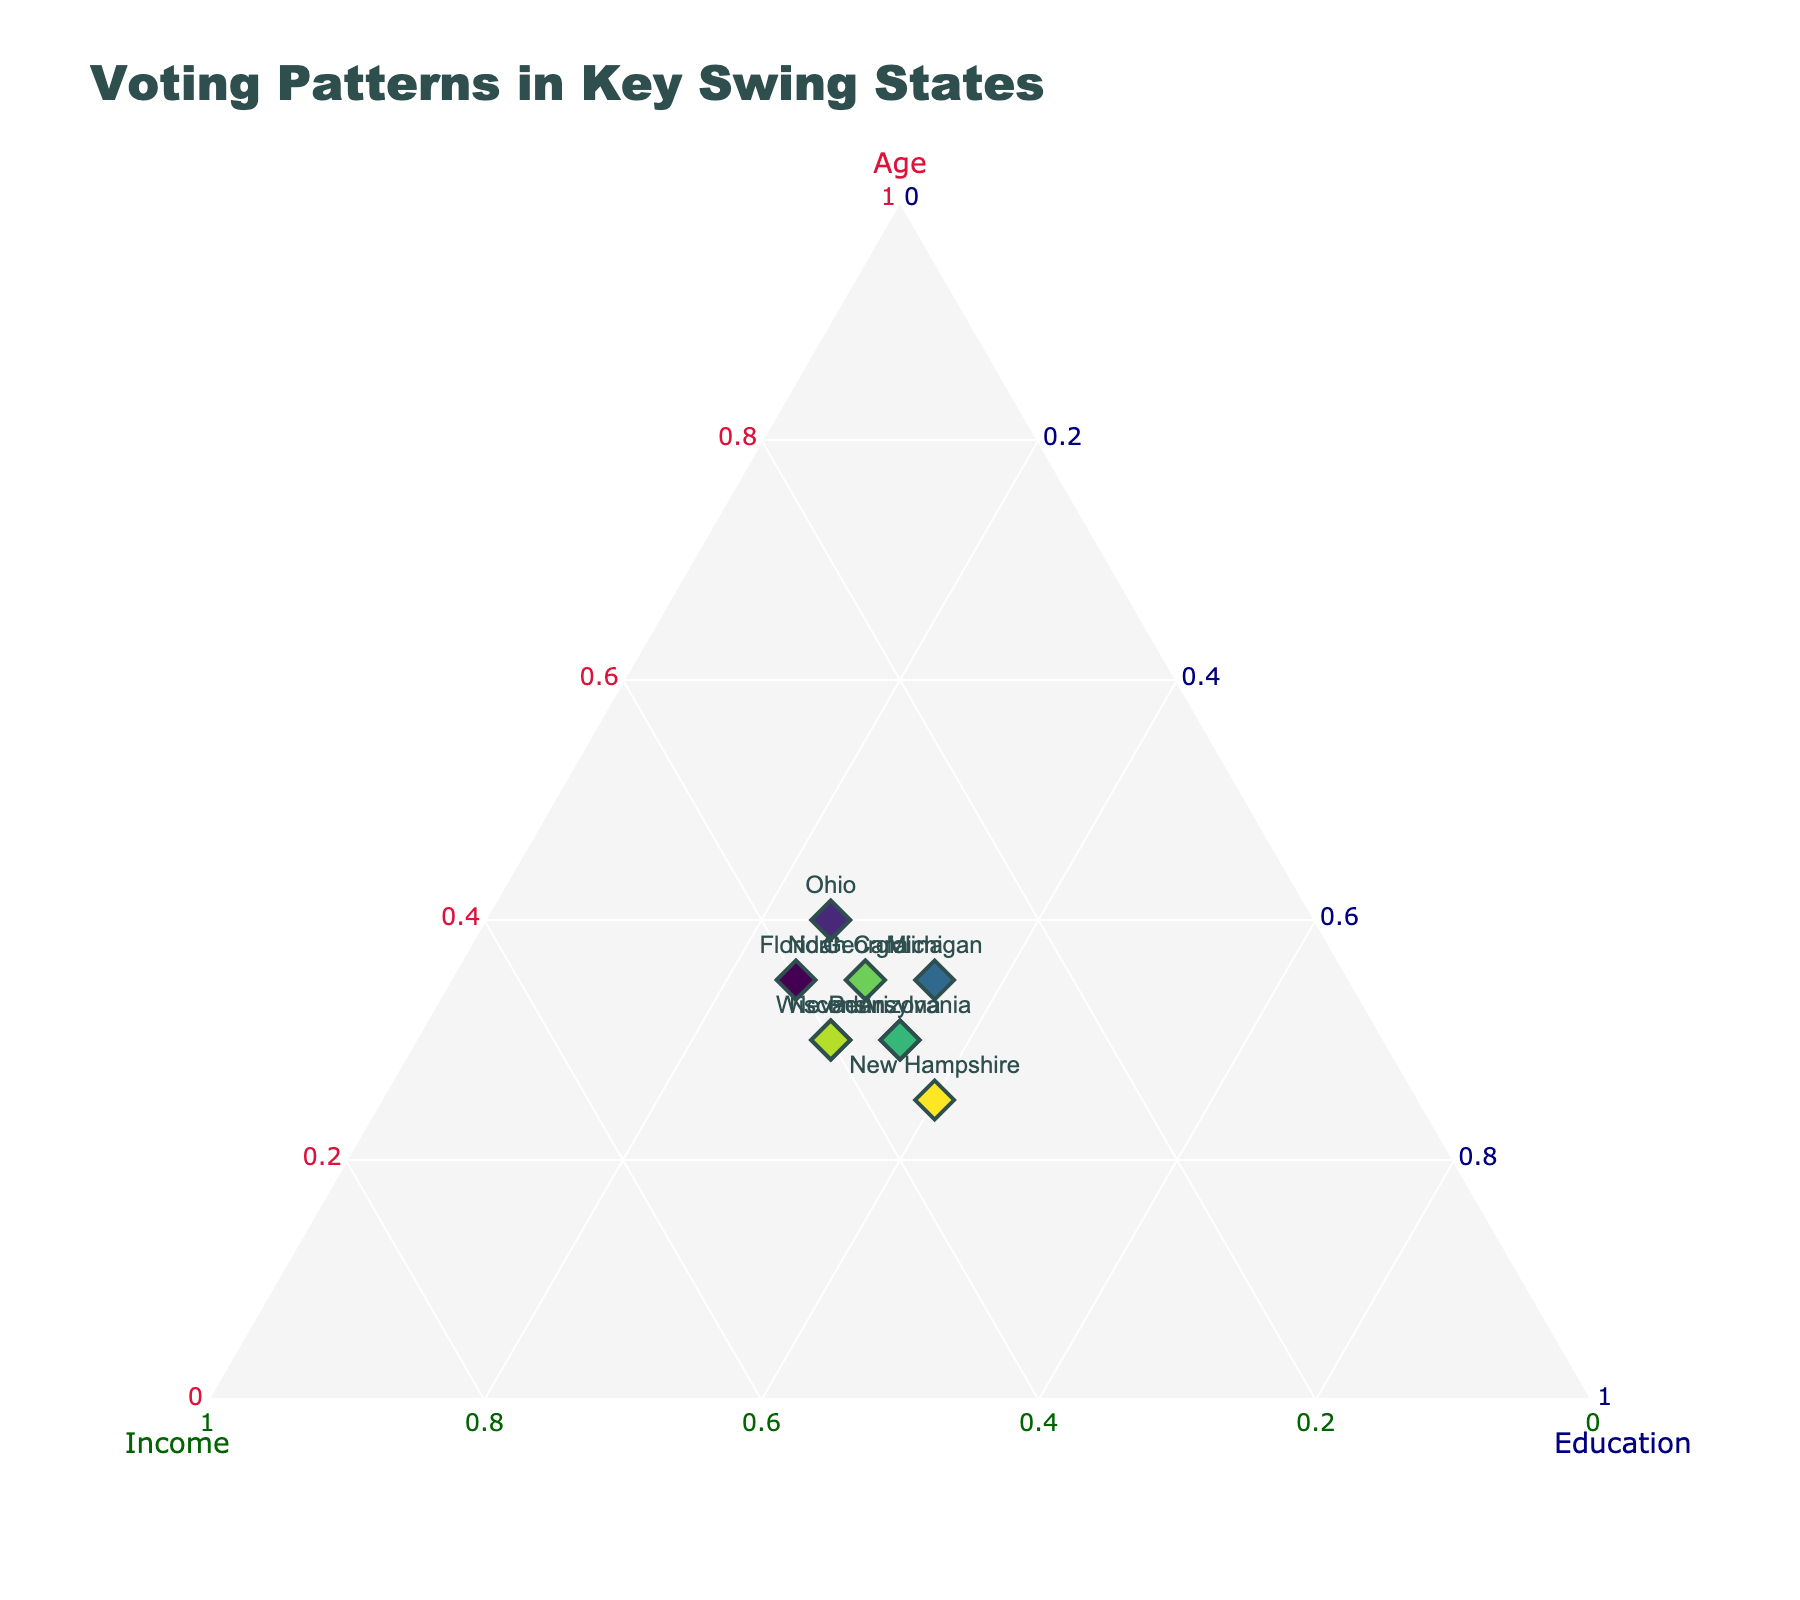What is the title of the figure? The title is usually located at the top of the figure and it's meant to provide a brief and descriptive insight into what the figure is representing.
Answer: Voting Patterns in Key Swing States Which state has the highest value for Education? By examining the vertex labeled 'Education', look for the point closest to this vertex. The point representing New Hampshire is closest to the Education vertex.
Answer: New Hampshire Which state represents the highest proportion of Income? The state with the point closest to the vertex labeled 'Income' has the highest proportion of Income. The point representing Wisconsin is closest to the Income vertex.
Answer: Wisconsin Among Florida and Ohio, which state has a higher proportion of Age? Examine the positions of Florida and Ohio relative to the 'Age' vertex. Florida’s point is closer to the 'Age' vertex than Ohio’s.
Answer: Florida What is the combined proportion of Age and Education for Michigan? Identify the position of Michigan on the ternary plot. Michigan has Age at 0.35 and Education at 0.35. Summing these values: 0.35 + 0.35 = 0.70.
Answer: 0.70 Which state has an equal proportion for Income and Education? Look for points where the 'Income' and 'Education' values are equal. Pennsylvania and Arizona both have 35% Income and 35% Education.
Answer: Pennsylvania and Arizona Compare Georgia and Nevada: which state has a higher Education proportion? Evaluate the position of each state in relation to the 'Education' vertex. Georgia's point is further from the Education vertex at 30%, while Nevada's is also at 30%. Thus, both share the same proportion.
Answer: Both equal at 30% Which state shows the most balanced proportions among Age, Income, and Education? Look for the state closest to the center of the ternary plot, indicating a balanced proportion. North Carolina, with proportions of 0.35 Age, 0.35 Income, and 0.30 Education, appears the most balanced.
Answer: North Carolina What is the average proportion of Income for all the states? To compute this, sum the Income values of all states and divide by the number of states: (0.40 + 0.35 + 0.35 + 0.30 + 0.40 + 0.35 + 0.35 + 0.35 + 0.40 + 0.35) / 10 = 0.365.
Answer: 0.365 